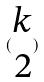<formula> <loc_0><loc_0><loc_500><loc_500>( \begin{matrix} k \\ 2 \end{matrix} )</formula> 